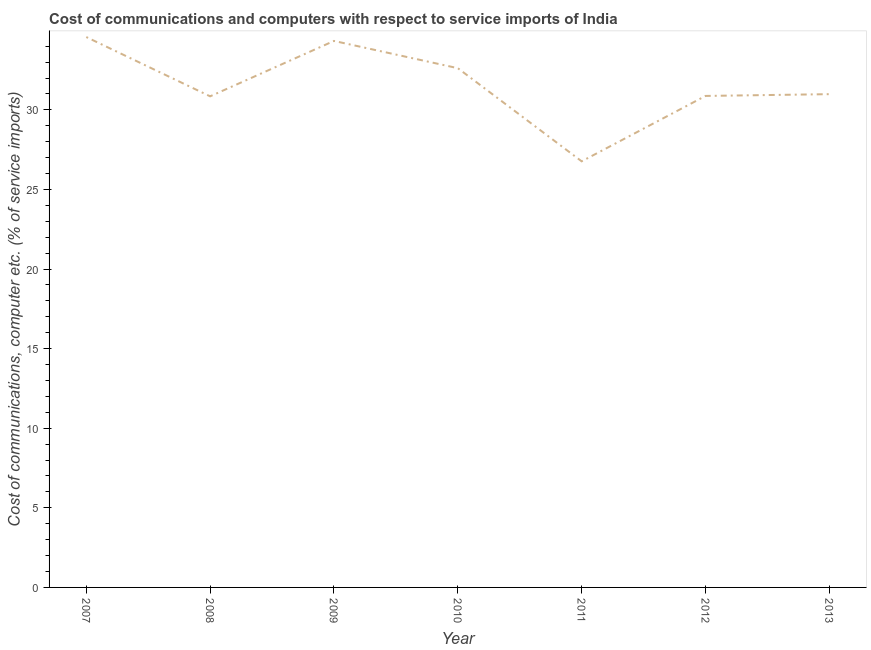What is the cost of communications and computer in 2012?
Your answer should be very brief. 30.87. Across all years, what is the maximum cost of communications and computer?
Offer a terse response. 34.57. Across all years, what is the minimum cost of communications and computer?
Offer a terse response. 26.77. What is the sum of the cost of communications and computer?
Make the answer very short. 221. What is the difference between the cost of communications and computer in 2009 and 2013?
Your answer should be very brief. 3.34. What is the average cost of communications and computer per year?
Offer a very short reply. 31.57. What is the median cost of communications and computer?
Your answer should be very brief. 30.99. What is the ratio of the cost of communications and computer in 2008 to that in 2012?
Your answer should be very brief. 1. What is the difference between the highest and the second highest cost of communications and computer?
Your answer should be compact. 0.25. Is the sum of the cost of communications and computer in 2008 and 2013 greater than the maximum cost of communications and computer across all years?
Keep it short and to the point. Yes. What is the difference between the highest and the lowest cost of communications and computer?
Offer a very short reply. 7.81. How many lines are there?
Your answer should be compact. 1. How many years are there in the graph?
Your answer should be compact. 7. Does the graph contain any zero values?
Offer a terse response. No. Does the graph contain grids?
Ensure brevity in your answer.  No. What is the title of the graph?
Offer a very short reply. Cost of communications and computers with respect to service imports of India. What is the label or title of the X-axis?
Provide a succinct answer. Year. What is the label or title of the Y-axis?
Offer a very short reply. Cost of communications, computer etc. (% of service imports). What is the Cost of communications, computer etc. (% of service imports) in 2007?
Offer a very short reply. 34.57. What is the Cost of communications, computer etc. (% of service imports) of 2008?
Your answer should be very brief. 30.85. What is the Cost of communications, computer etc. (% of service imports) in 2009?
Offer a terse response. 34.33. What is the Cost of communications, computer etc. (% of service imports) in 2010?
Your answer should be very brief. 32.62. What is the Cost of communications, computer etc. (% of service imports) of 2011?
Offer a very short reply. 26.77. What is the Cost of communications, computer etc. (% of service imports) of 2012?
Provide a short and direct response. 30.87. What is the Cost of communications, computer etc. (% of service imports) in 2013?
Keep it short and to the point. 30.99. What is the difference between the Cost of communications, computer etc. (% of service imports) in 2007 and 2008?
Your answer should be compact. 3.72. What is the difference between the Cost of communications, computer etc. (% of service imports) in 2007 and 2009?
Your response must be concise. 0.25. What is the difference between the Cost of communications, computer etc. (% of service imports) in 2007 and 2010?
Your response must be concise. 1.96. What is the difference between the Cost of communications, computer etc. (% of service imports) in 2007 and 2011?
Provide a short and direct response. 7.81. What is the difference between the Cost of communications, computer etc. (% of service imports) in 2007 and 2012?
Your answer should be compact. 3.7. What is the difference between the Cost of communications, computer etc. (% of service imports) in 2007 and 2013?
Ensure brevity in your answer.  3.59. What is the difference between the Cost of communications, computer etc. (% of service imports) in 2008 and 2009?
Provide a short and direct response. -3.48. What is the difference between the Cost of communications, computer etc. (% of service imports) in 2008 and 2010?
Offer a terse response. -1.77. What is the difference between the Cost of communications, computer etc. (% of service imports) in 2008 and 2011?
Ensure brevity in your answer.  4.08. What is the difference between the Cost of communications, computer etc. (% of service imports) in 2008 and 2012?
Provide a succinct answer. -0.02. What is the difference between the Cost of communications, computer etc. (% of service imports) in 2008 and 2013?
Ensure brevity in your answer.  -0.14. What is the difference between the Cost of communications, computer etc. (% of service imports) in 2009 and 2010?
Offer a very short reply. 1.71. What is the difference between the Cost of communications, computer etc. (% of service imports) in 2009 and 2011?
Offer a terse response. 7.56. What is the difference between the Cost of communications, computer etc. (% of service imports) in 2009 and 2012?
Ensure brevity in your answer.  3.45. What is the difference between the Cost of communications, computer etc. (% of service imports) in 2009 and 2013?
Offer a very short reply. 3.34. What is the difference between the Cost of communications, computer etc. (% of service imports) in 2010 and 2011?
Ensure brevity in your answer.  5.85. What is the difference between the Cost of communications, computer etc. (% of service imports) in 2010 and 2012?
Keep it short and to the point. 1.74. What is the difference between the Cost of communications, computer etc. (% of service imports) in 2010 and 2013?
Keep it short and to the point. 1.63. What is the difference between the Cost of communications, computer etc. (% of service imports) in 2011 and 2012?
Ensure brevity in your answer.  -4.11. What is the difference between the Cost of communications, computer etc. (% of service imports) in 2011 and 2013?
Keep it short and to the point. -4.22. What is the difference between the Cost of communications, computer etc. (% of service imports) in 2012 and 2013?
Offer a terse response. -0.11. What is the ratio of the Cost of communications, computer etc. (% of service imports) in 2007 to that in 2008?
Offer a very short reply. 1.12. What is the ratio of the Cost of communications, computer etc. (% of service imports) in 2007 to that in 2010?
Your answer should be compact. 1.06. What is the ratio of the Cost of communications, computer etc. (% of service imports) in 2007 to that in 2011?
Your answer should be very brief. 1.29. What is the ratio of the Cost of communications, computer etc. (% of service imports) in 2007 to that in 2012?
Ensure brevity in your answer.  1.12. What is the ratio of the Cost of communications, computer etc. (% of service imports) in 2007 to that in 2013?
Provide a short and direct response. 1.12. What is the ratio of the Cost of communications, computer etc. (% of service imports) in 2008 to that in 2009?
Provide a short and direct response. 0.9. What is the ratio of the Cost of communications, computer etc. (% of service imports) in 2008 to that in 2010?
Give a very brief answer. 0.95. What is the ratio of the Cost of communications, computer etc. (% of service imports) in 2008 to that in 2011?
Give a very brief answer. 1.15. What is the ratio of the Cost of communications, computer etc. (% of service imports) in 2009 to that in 2010?
Keep it short and to the point. 1.05. What is the ratio of the Cost of communications, computer etc. (% of service imports) in 2009 to that in 2011?
Your response must be concise. 1.28. What is the ratio of the Cost of communications, computer etc. (% of service imports) in 2009 to that in 2012?
Offer a terse response. 1.11. What is the ratio of the Cost of communications, computer etc. (% of service imports) in 2009 to that in 2013?
Offer a terse response. 1.11. What is the ratio of the Cost of communications, computer etc. (% of service imports) in 2010 to that in 2011?
Make the answer very short. 1.22. What is the ratio of the Cost of communications, computer etc. (% of service imports) in 2010 to that in 2012?
Your answer should be very brief. 1.06. What is the ratio of the Cost of communications, computer etc. (% of service imports) in 2010 to that in 2013?
Give a very brief answer. 1.05. What is the ratio of the Cost of communications, computer etc. (% of service imports) in 2011 to that in 2012?
Your answer should be very brief. 0.87. What is the ratio of the Cost of communications, computer etc. (% of service imports) in 2011 to that in 2013?
Your response must be concise. 0.86. 